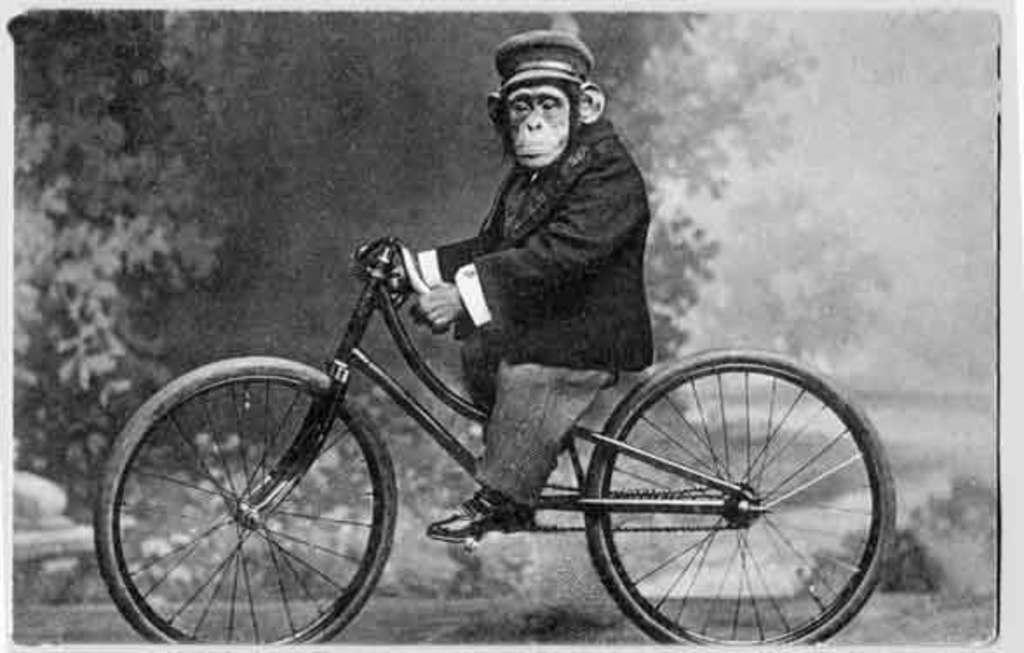What animal is the main subject of the picture? There is a chimpanzee in the picture. What is the chimpanzee doing in the picture? The chimpanzee is riding a bicycle. What is the chimpanzee wearing in the picture? The chimpanzee is wearing a cap. What can be seen in the background of the picture? There are trees visible in the background of the picture. Where is the cemetery located in the picture? There is no cemetery present in the picture; it features a chimpanzee riding a bicycle. How many crows are sitting on the shelf in the picture? There are no crows or shelves present in the picture. 